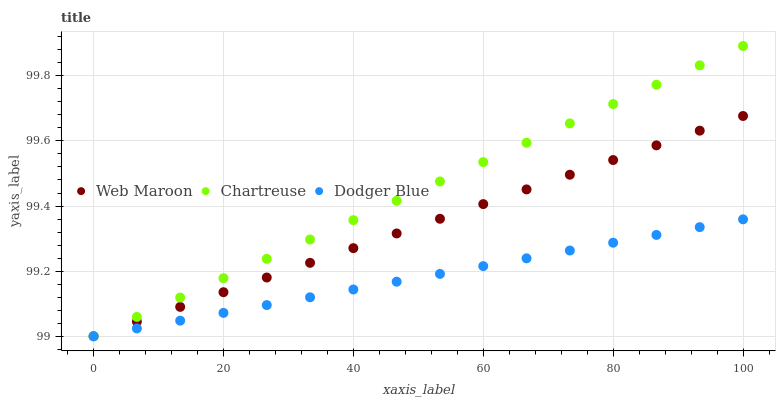Does Dodger Blue have the minimum area under the curve?
Answer yes or no. Yes. Does Chartreuse have the maximum area under the curve?
Answer yes or no. Yes. Does Web Maroon have the minimum area under the curve?
Answer yes or no. No. Does Web Maroon have the maximum area under the curve?
Answer yes or no. No. Is Dodger Blue the smoothest?
Answer yes or no. Yes. Is Chartreuse the roughest?
Answer yes or no. Yes. Is Web Maroon the smoothest?
Answer yes or no. No. Is Web Maroon the roughest?
Answer yes or no. No. Does Dodger Blue have the lowest value?
Answer yes or no. Yes. Does Chartreuse have the highest value?
Answer yes or no. Yes. Does Web Maroon have the highest value?
Answer yes or no. No. Does Dodger Blue intersect Web Maroon?
Answer yes or no. Yes. Is Dodger Blue less than Web Maroon?
Answer yes or no. No. Is Dodger Blue greater than Web Maroon?
Answer yes or no. No. 